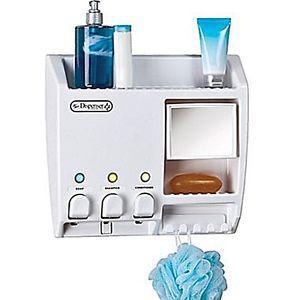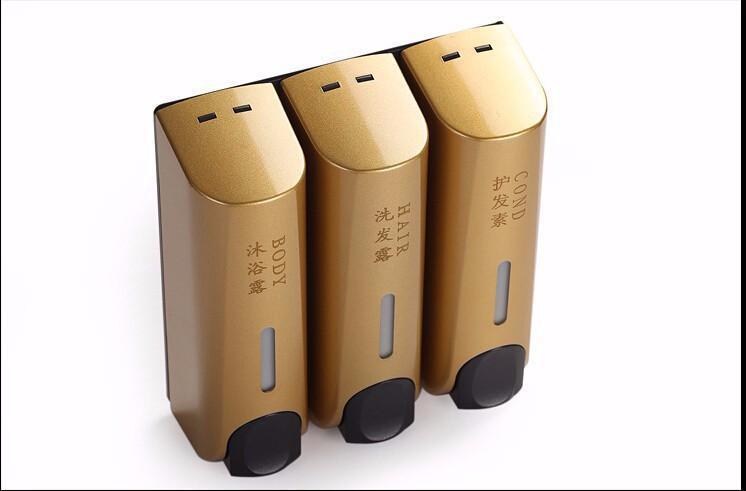The first image is the image on the left, the second image is the image on the right. Evaluate the accuracy of this statement regarding the images: "There are two cleaning products on the left and three on the right.". Is it true? Answer yes or no. No. The first image is the image on the left, the second image is the image on the right. Evaluate the accuracy of this statement regarding the images: "An image shows three side-by-side gold dispensers with black push buttons.". Is it true? Answer yes or no. Yes. 